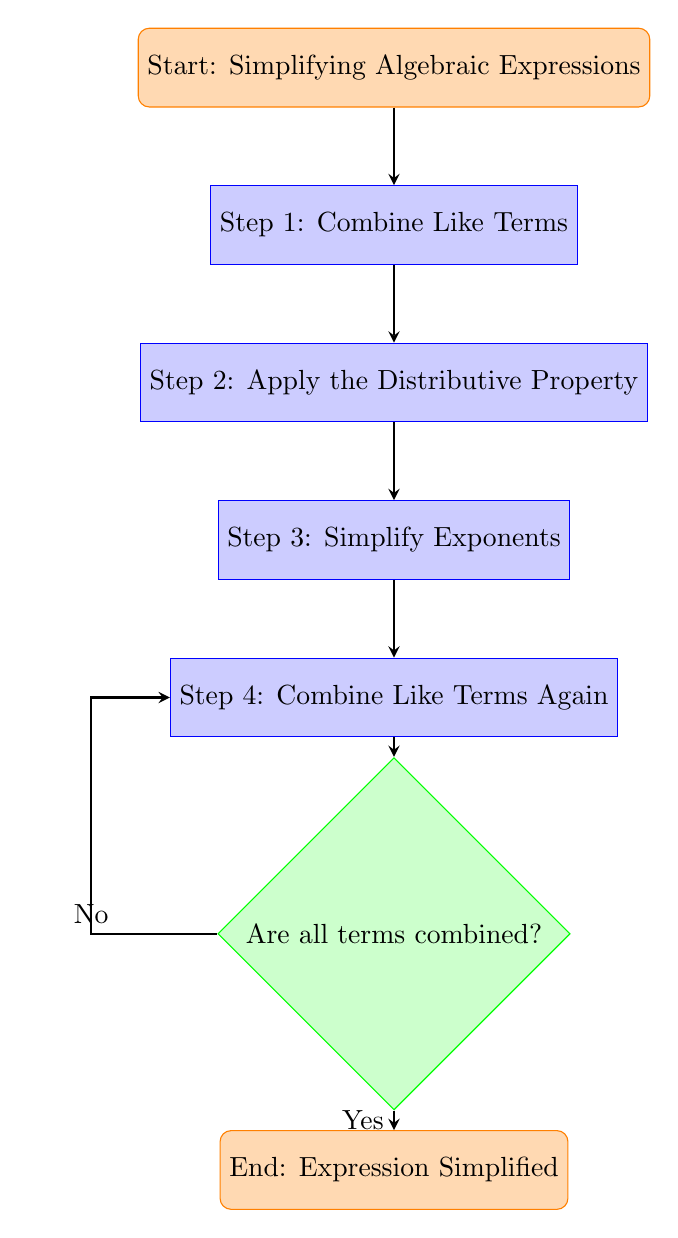What is the first step in the flow chart? The flow chart starts with the node labeled "Start: Simplifying Algebraic Expressions," which leads to "Step 1: Combine Like Terms." Therefore, the first step is what's indicated in this second node.
Answer: Combine Like Terms How many steps are there in the process? The flow chart has four steps labeled from "Step 1" to "Step 4." Each step represents a distinct action to take in simplifying algebraic expressions, totaling four steps.
Answer: Four What actions are taken before checking if all terms are combined? Before checking if all terms are combined, the flow chart indicates that you must complete four steps: "Combine Like Terms," "Apply the Distributive Property," "Simplify Exponents," and "Combine Like Terms Again." Thus, these actions must be taken prior to that decision point.
Answer: Four actions What happens if the answer to the decision question is "No"? If the answer to the decision question "Are all terms combined?" is "No," the flow chart shows that you return to "Step 4: Combine Like Terms Again." This indicates that you need to repeat that step until all terms are combined.
Answer: Return to Step 4 What signifies the end of the process in the flow chart? The end of the process is signified by the node labeled "End: Expression Simplified." This is where the flow chart concludes after all necessary steps have been completed and the expression is simplified.
Answer: End: Expression Simplified What is the second step in simplifying an algebraic expression according to the flow chart? The second step, following "Combine Like Terms," is labeled "Step 2: Apply the Distributive Property." This outlines the order in which the steps must be completed.
Answer: Apply the Distributive Property Are there any decision points in the flow chart? Yes, the flow chart contains one decision point, which is indicated by the node "Are all terms combined?" This point determines whether to proceed to the end or return to an earlier step in the process.
Answer: Yes How many nodes are there in the flow chart? The flow chart contains a total of six nodes, including the start and end nodes, as well as the four process steps and one decision node.
Answer: Six nodes 